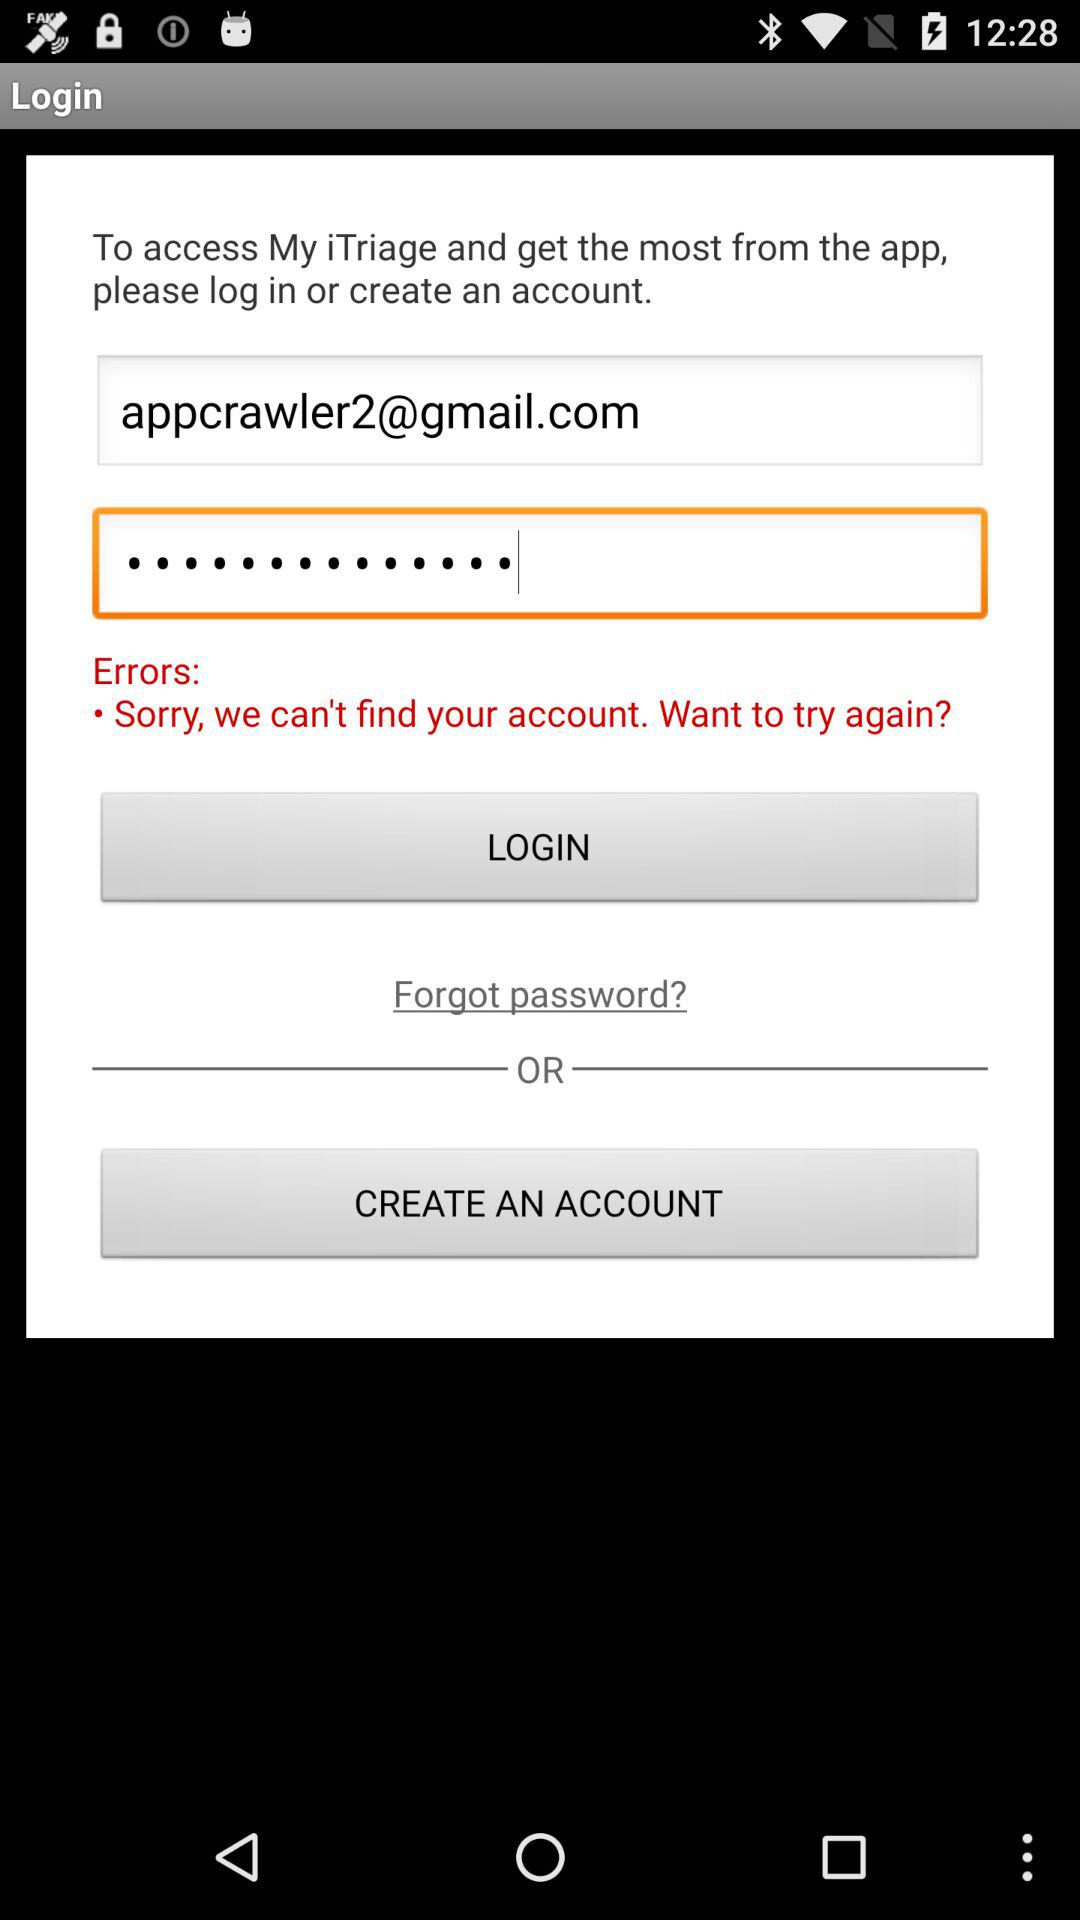How many text inputs have an error message?
Answer the question using a single word or phrase. 1 